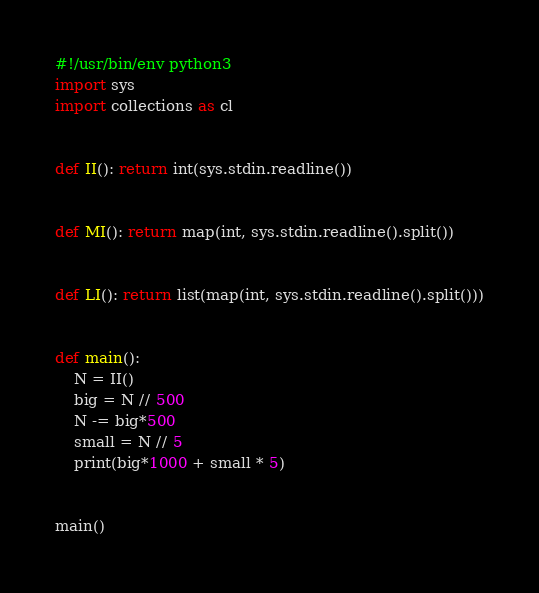<code> <loc_0><loc_0><loc_500><loc_500><_Python_>#!/usr/bin/env python3
import sys
import collections as cl


def II(): return int(sys.stdin.readline())


def MI(): return map(int, sys.stdin.readline().split())


def LI(): return list(map(int, sys.stdin.readline().split()))


def main():
    N = II()
    big = N // 500
    N -= big*500
    small = N // 5
    print(big*1000 + small * 5)


main()
</code> 